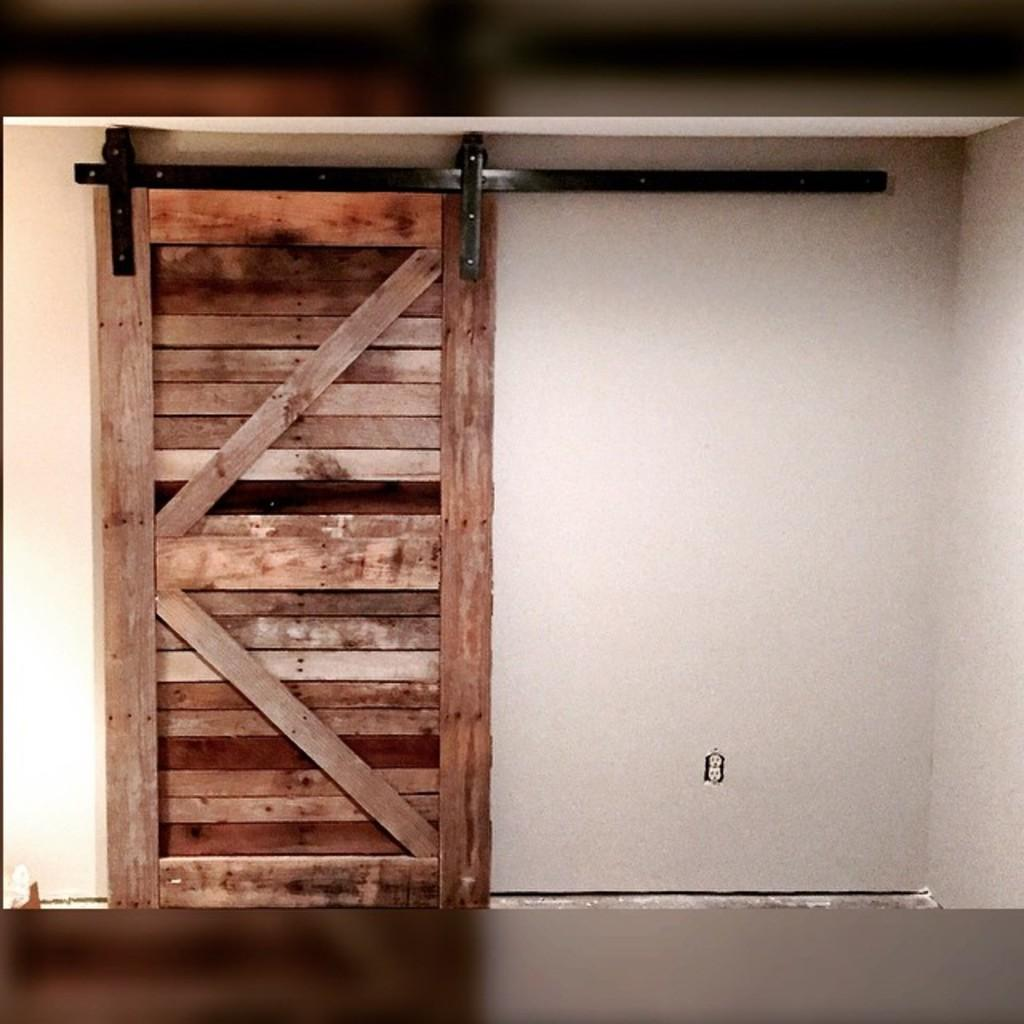What type of door is visible in the image? There is a wooden door in the image. Where is the wooden door located? The wooden door is on a wall. What route does the bucket take to reach the wooden door in the image? There is no bucket present in the image, so it cannot be determined how a bucket would reach the wooden door. 